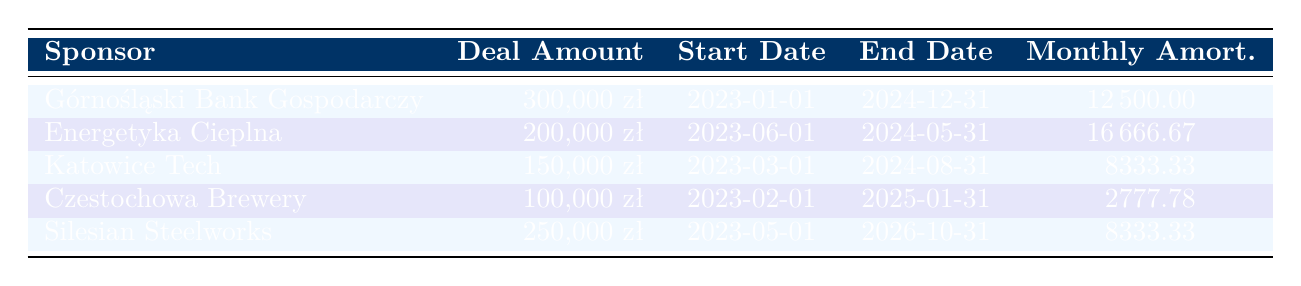What is the deal amount for Górnośląski Bank Gospodarczy? The table shows that the deal amount for Górnośląski Bank Gospodarczy is 300,000 zł.
Answer: 300,000 zł Which sponsor's deal ends first? Looking at the end dates, Energetyka Cieplna ends on 2024-05-31, while others have later end dates. Hence, the sponsor with the earliest end date is Energetyka Cieplna.
Answer: Energetyka Cieplna What is the total monthly amortization for all sponsorship deals? To find the total monthly amortization, sum the monthly amounts: 12,500 + 16,666.67 + 8,333.33 + 2,777.78 + 8,333.33 = 48,611.11.
Answer: 48,611.11 Is the contract length for Silesian Steelworks longer than that for Katowice Tech? Comparing their contract lengths, Silesian Steelworks has 30 months while Katowice Tech has 18 months. Since 30 is greater than 18, the statement is true.
Answer: Yes What is the average deal amount across all sponsors? The deal amounts are: 300,000, 200,000, 150,000, 100,000, 250,000. Their sum is 1,000,000. Dividing this by the number of sponsors (5) gives 1,000,000 / 5 = 200,000.
Answer: 200,000 How many sponsors have a monthly amortization amount greater than 10,000 zł? The monthly amortization amounts are: 12,500, 16,666.67, 8,333.33, 2,777.78, and 8,333.33. The amounts greater than 10,000 zł are from Górnośląski Bank Gospodarczy and Energetyka Cieplna, totaling 2 sponsors.
Answer: 2 What is the total deal amount for sponsors whose contracts have a length of 24 months or longer? The sponsors with 24 months or longer are Górnośląski Bank Gospodarczy (300,000), Czestochowa Brewery (100,000), and Silesian Steelworks (250,000). Summing these gives: 300,000 + 100,000 + 250,000 = 650,000.
Answer: 650,000 Does Katowice Tech have the smallest deal amount among the three sponsors listed first? The amounts for the first three sponsors are 300,000 (Górnośląski Bank Gospodarczy), 200,000 (Energetyka Cieplna), and 150,000 (Katowice Tech). Since 150,000 is the smallest, the answer is yes.
Answer: Yes 